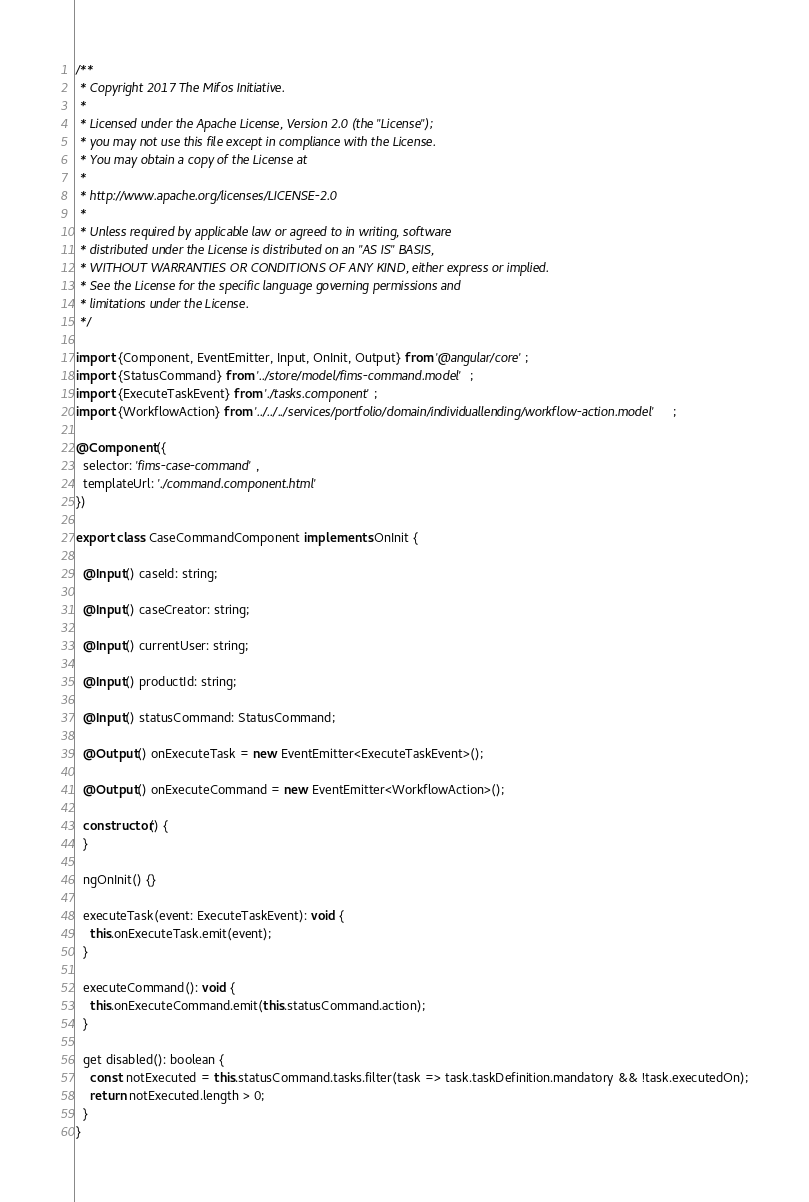Convert code to text. <code><loc_0><loc_0><loc_500><loc_500><_TypeScript_>/**
 * Copyright 2017 The Mifos Initiative.
 *
 * Licensed under the Apache License, Version 2.0 (the "License");
 * you may not use this file except in compliance with the License.
 * You may obtain a copy of the License at
 *
 * http://www.apache.org/licenses/LICENSE-2.0
 *
 * Unless required by applicable law or agreed to in writing, software
 * distributed under the License is distributed on an "AS IS" BASIS,
 * WITHOUT WARRANTIES OR CONDITIONS OF ANY KIND, either express or implied.
 * See the License for the specific language governing permissions and
 * limitations under the License.
 */

import {Component, EventEmitter, Input, OnInit, Output} from '@angular/core';
import {StatusCommand} from '../store/model/fims-command.model';
import {ExecuteTaskEvent} from './tasks.component';
import {WorkflowAction} from '../../../services/portfolio/domain/individuallending/workflow-action.model';

@Component({
  selector: 'fims-case-command',
  templateUrl: './command.component.html'
})

export class CaseCommandComponent implements OnInit {

  @Input() caseId: string;

  @Input() caseCreator: string;

  @Input() currentUser: string;

  @Input() productId: string;

  @Input() statusCommand: StatusCommand;

  @Output() onExecuteTask = new EventEmitter<ExecuteTaskEvent>();

  @Output() onExecuteCommand = new EventEmitter<WorkflowAction>();

  constructor() {
  }

  ngOnInit() {}

  executeTask(event: ExecuteTaskEvent): void {
    this.onExecuteTask.emit(event);
  }

  executeCommand(): void {
    this.onExecuteCommand.emit(this.statusCommand.action);
  }

  get disabled(): boolean {
    const notExecuted = this.statusCommand.tasks.filter(task => task.taskDefinition.mandatory && !task.executedOn);
    return notExecuted.length > 0;
  }
}
</code> 